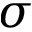Convert formula to latex. <formula><loc_0><loc_0><loc_500><loc_500>\sigma</formula> 